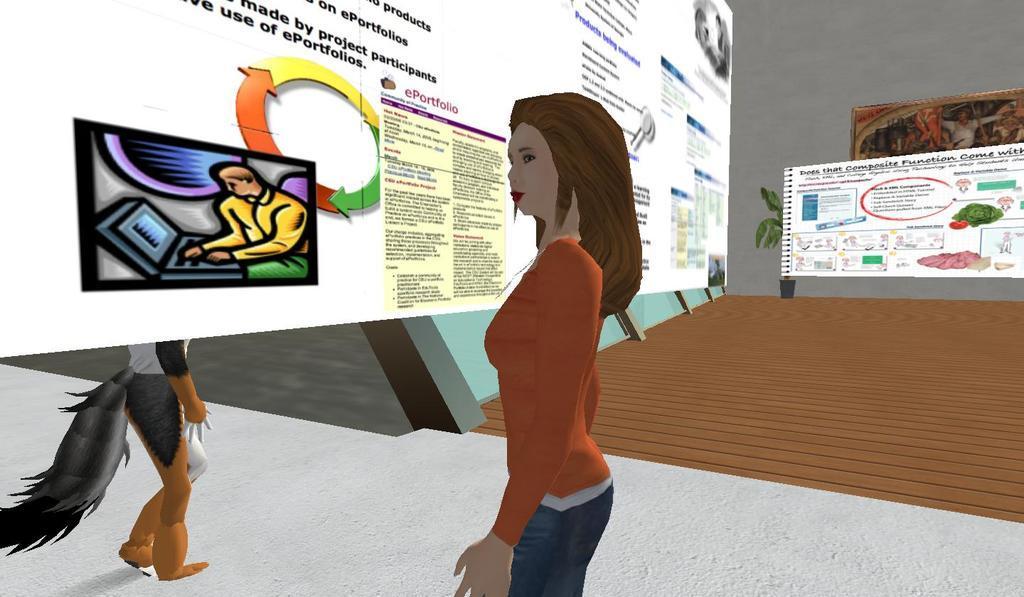Can you describe this image briefly? As we can see in the image there is an animation of wall, photo frame, banners and a woman standing in the middle. On the left side there is an animal. 